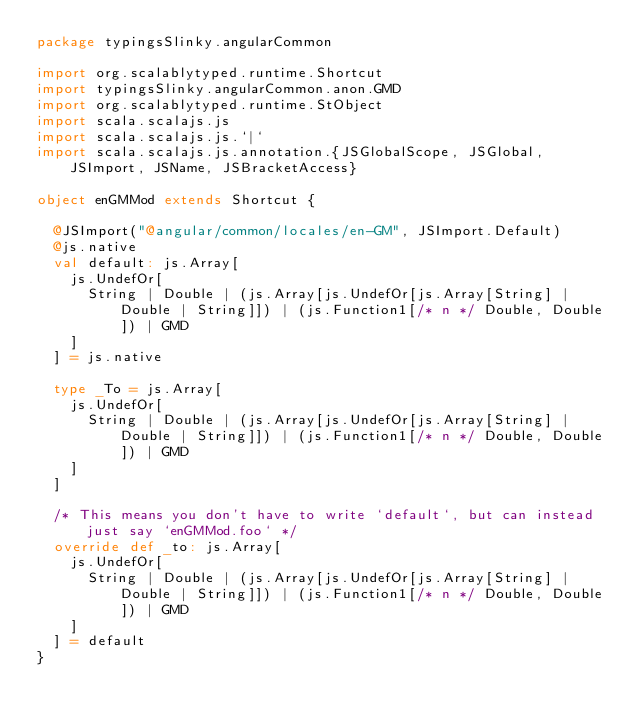Convert code to text. <code><loc_0><loc_0><loc_500><loc_500><_Scala_>package typingsSlinky.angularCommon

import org.scalablytyped.runtime.Shortcut
import typingsSlinky.angularCommon.anon.GMD
import org.scalablytyped.runtime.StObject
import scala.scalajs.js
import scala.scalajs.js.`|`
import scala.scalajs.js.annotation.{JSGlobalScope, JSGlobal, JSImport, JSName, JSBracketAccess}

object enGMMod extends Shortcut {
  
  @JSImport("@angular/common/locales/en-GM", JSImport.Default)
  @js.native
  val default: js.Array[
    js.UndefOr[
      String | Double | (js.Array[js.UndefOr[js.Array[String] | Double | String]]) | (js.Function1[/* n */ Double, Double]) | GMD
    ]
  ] = js.native
  
  type _To = js.Array[
    js.UndefOr[
      String | Double | (js.Array[js.UndefOr[js.Array[String] | Double | String]]) | (js.Function1[/* n */ Double, Double]) | GMD
    ]
  ]
  
  /* This means you don't have to write `default`, but can instead just say `enGMMod.foo` */
  override def _to: js.Array[
    js.UndefOr[
      String | Double | (js.Array[js.UndefOr[js.Array[String] | Double | String]]) | (js.Function1[/* n */ Double, Double]) | GMD
    ]
  ] = default
}
</code> 